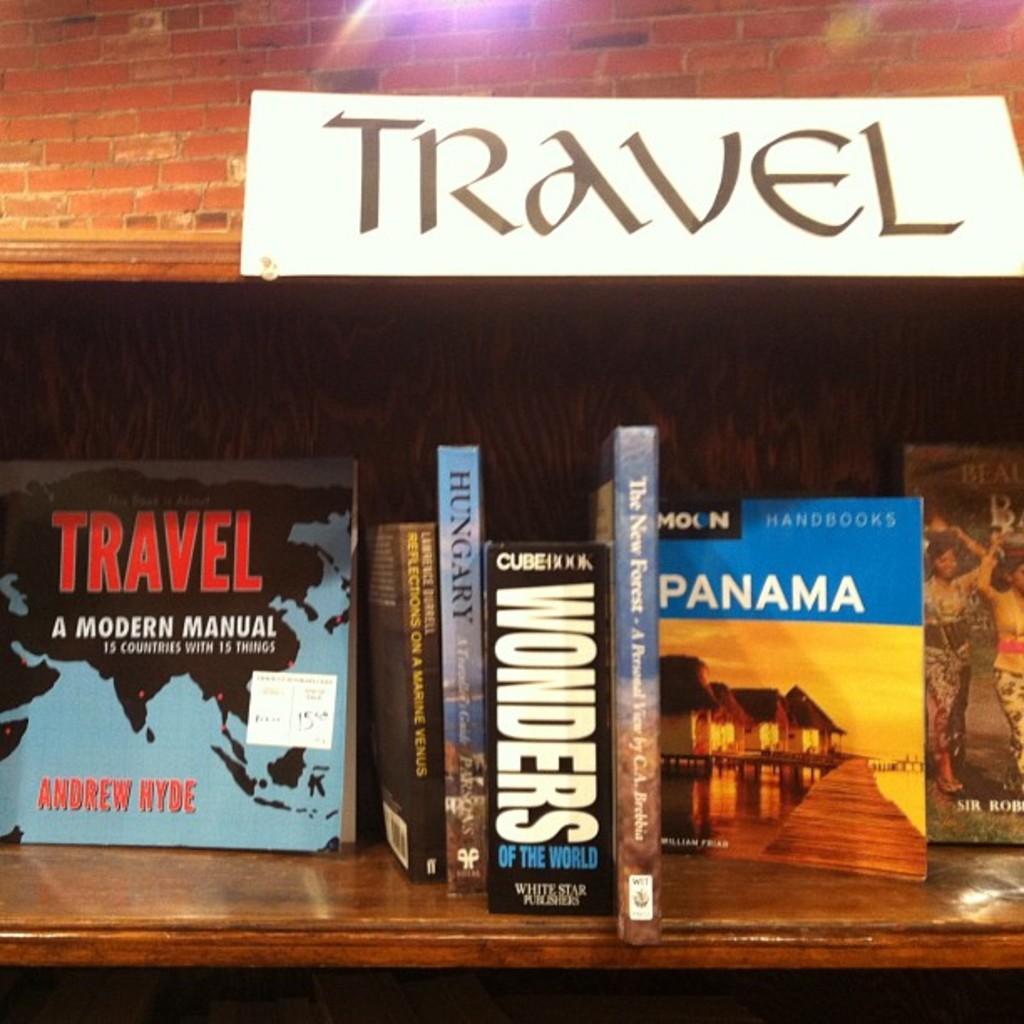Who wrote,"travel a modern manual"?
Give a very brief answer. Andrew hyde. What is the title of the left book?
Offer a very short reply. Travel a modern manual. 